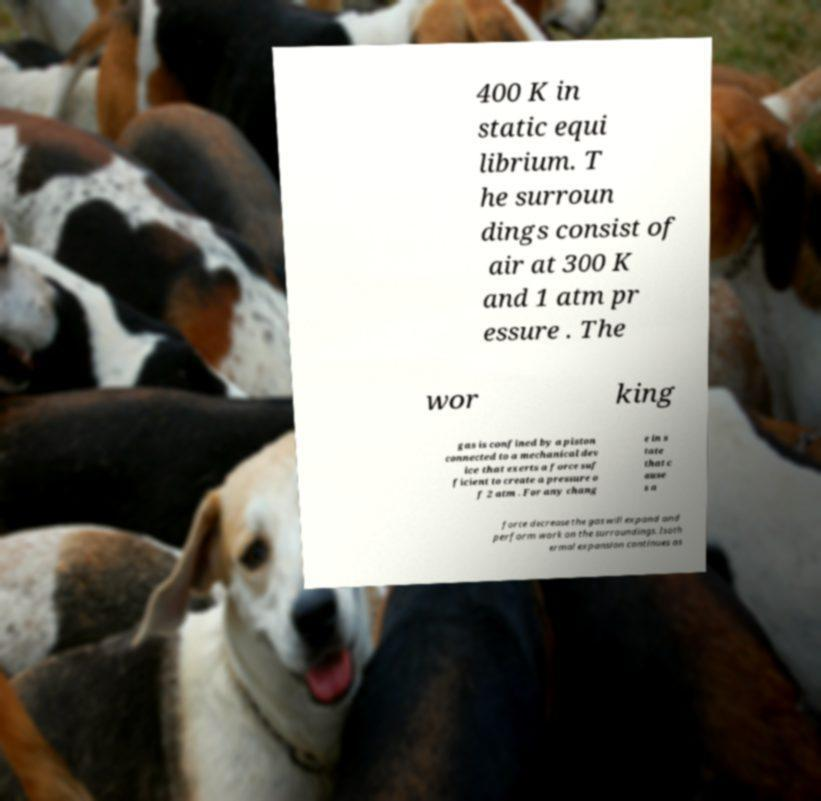There's text embedded in this image that I need extracted. Can you transcribe it verbatim? 400 K in static equi librium. T he surroun dings consist of air at 300 K and 1 atm pr essure . The wor king gas is confined by a piston connected to a mechanical dev ice that exerts a force suf ficient to create a pressure o f 2 atm . For any chang e in s tate that c ause s a force decrease the gas will expand and perform work on the surroundings. Isoth ermal expansion continues as 